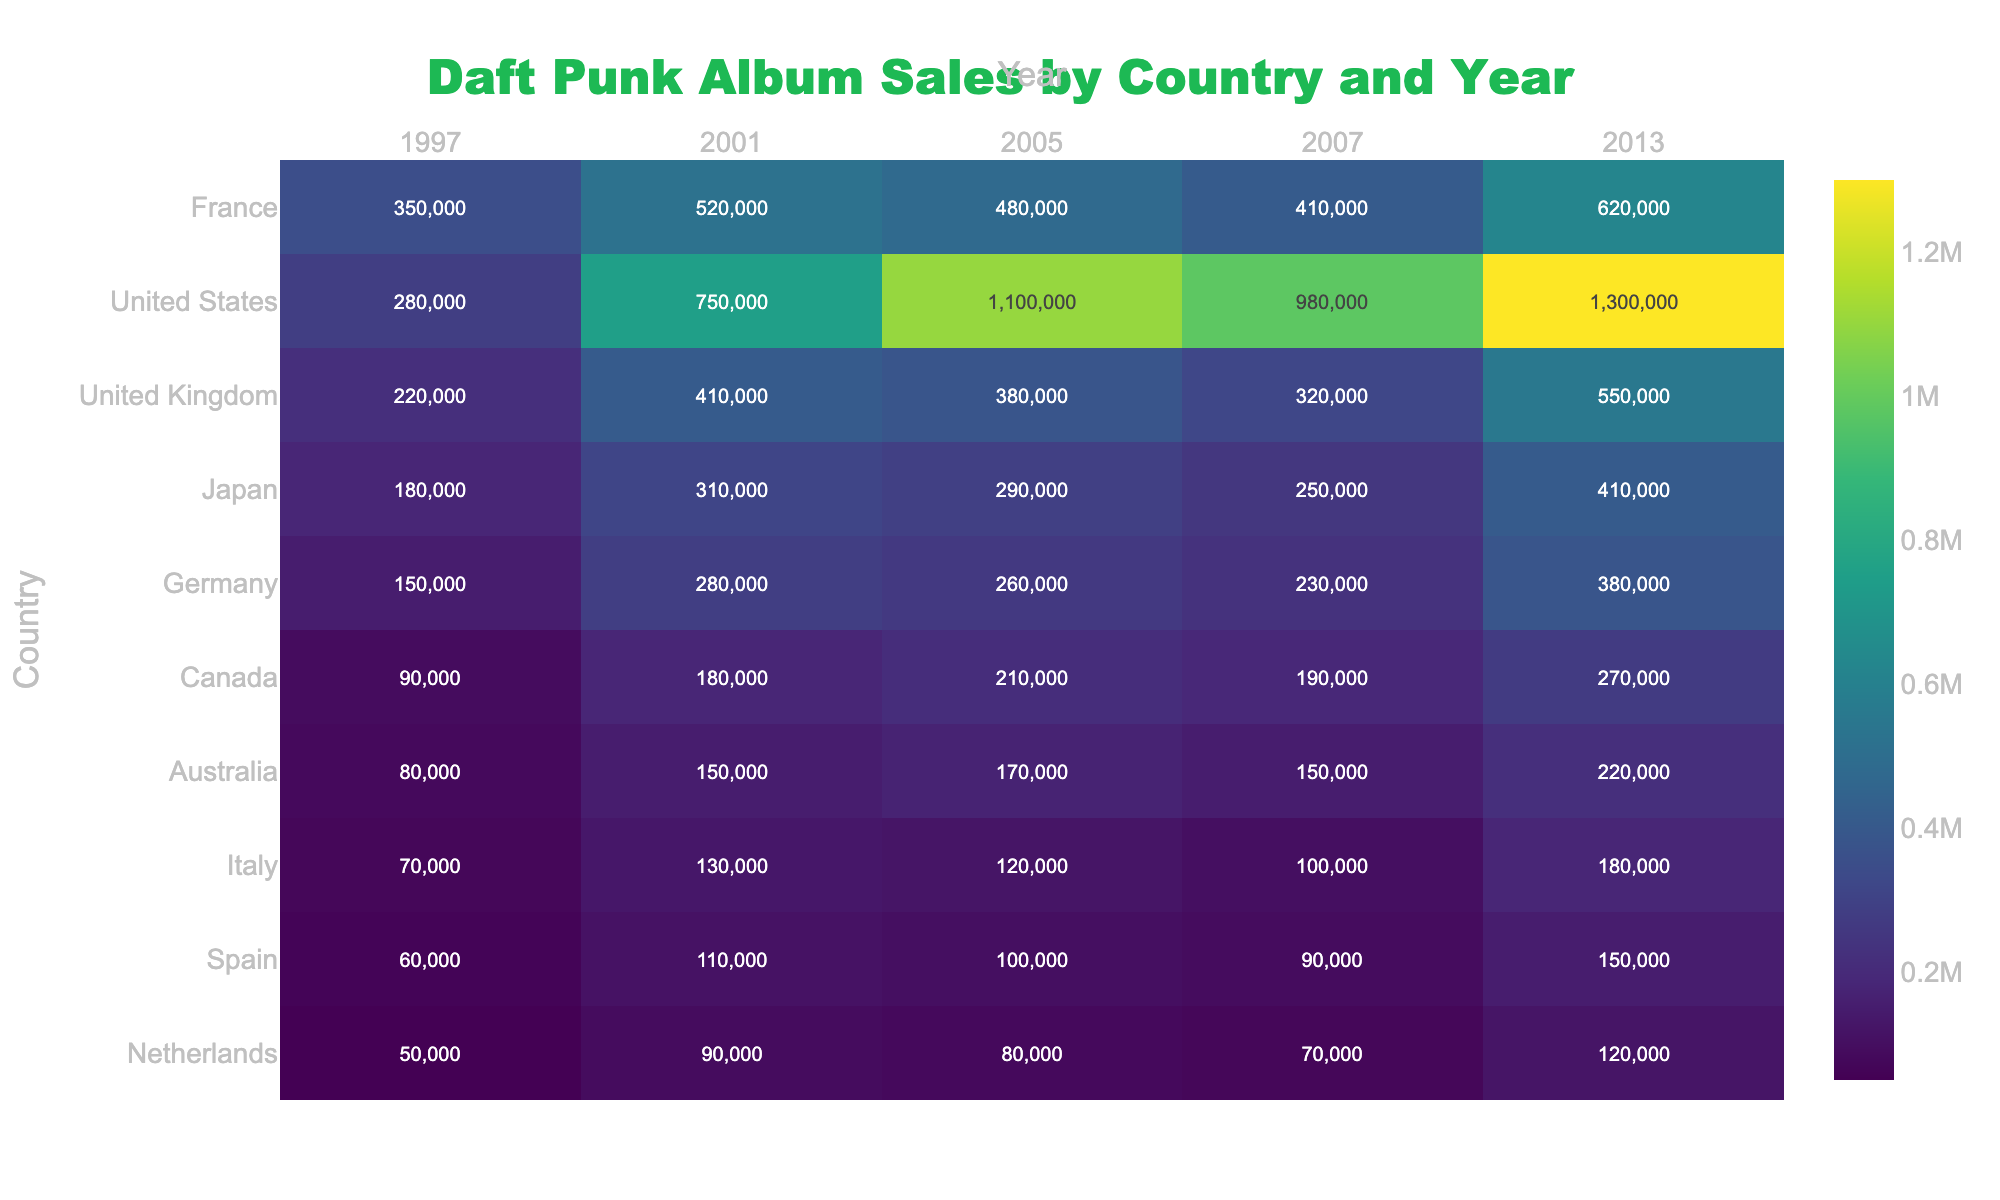What are the total album sales in France for the year 2005? Referring to the table, the album sales in France for the year 2005 is listed as 480,000.
Answer: 480,000 Which country had the highest album sales in 2013? In 2013, we look for the maximum sales value across all countries. The United States has the highest at 1,300,000.
Answer: United States What is the difference in album sales for the United Kingdom from 2001 to 2007? In 2001, the United Kingdom had sales of 410,000 and in 2007, the sales were 320,000. The difference is calculated as 410,000 - 320,000 = 90,000.
Answer: 90,000 What was the average album sales across all countries for the year 1997? To find the average for 1997, we sum the sales: (350,000 + 280,000 + 220,000 + 180,000 + 150,000 + 90,000 + 80,000 + 70,000 + 60,000 + 50,000) = 1,570,000. There are 10 countries, so we divide: 1,570,000 / 10 = 157,000.
Answer: 157,000 Did Japan's album sales ever exceed Germany's in any year? Reviewing the sales figures, Japan's sales were greater than Germany's in 2001 (310,000 vs 280,000) and 2013 (410,000 vs 380,000). Thus, yes, Japan's sales did exceed Germany's in those years.
Answer: Yes What is the total album sales for Canada from 1997 to 2013? The sales figures for Canada are 90,000 in 1997, 180,000 in 2001, 210,000 in 2005, 190,000 in 2007, and 270,000 in 2013. Summing these gives: 90,000 + 180,000 + 210,000 + 190,000 + 270,000 = 1,040,000.
Answer: 1,040,000 Which country had the lowest album sales in 2005? Checking the table, the lowest sales in 2005 was found to be from Italy with 120,000 sales.
Answer: Italy In which year did the album sales in Australia first exceed 200,000? Looking at Australia’s sales, in the years 1997 (80,000), 2001 (150,000), 2005 (170,000), 2007 (150,000), and 2013 (220,000), sales first exceeded 200,000 in 2013.
Answer: 2013 Calculate the total album sales in the United States for the years provided. The album sales in the United States for the years are: 280,000 (1997) + 750,000 (2001) + 1,100,000 (2005) + 980,000 (2007) + 1,300,000 (2013) = 4,410,000.
Answer: 4,410,000 Which country saw the most significant increase in album sales from 2001 to 2013? Comparing the sales for the year 2001 and 2013, we determine the increase for each country: United States: 1300000 - 750000 = 550000, France: 620000 - 520000 = 100000, United Kingdom: 550000 - 410000 = 140000, etc. The largest increase is 550,000 for the United States.
Answer: United States 